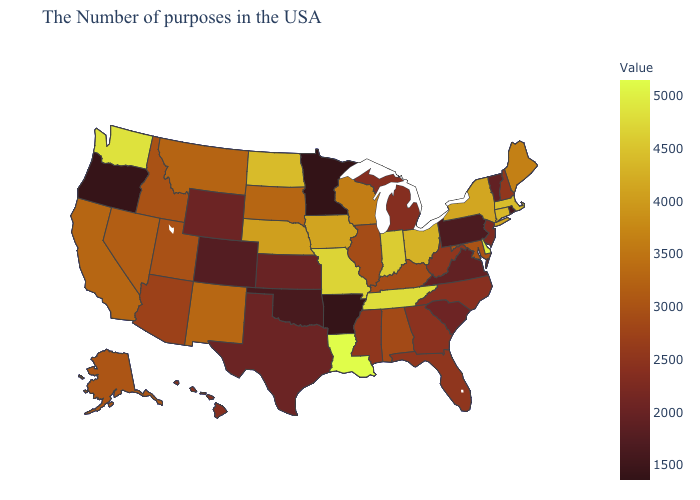Does Maryland have the highest value in the USA?
Concise answer only. No. 